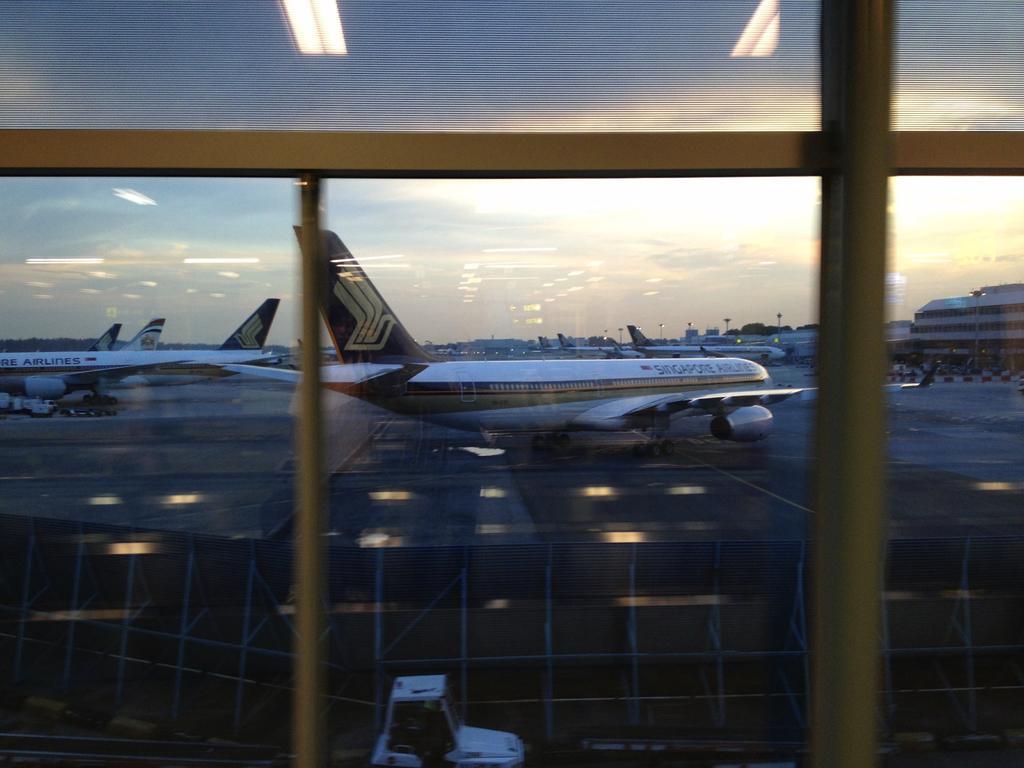Could you give a brief overview of what you see in this image? This image is clicked from a window. In the front, we can see many planes. At the bottom, there is a road. And we can see a vehicle in white color. At the top, there is sky. On the right, there is a building. 